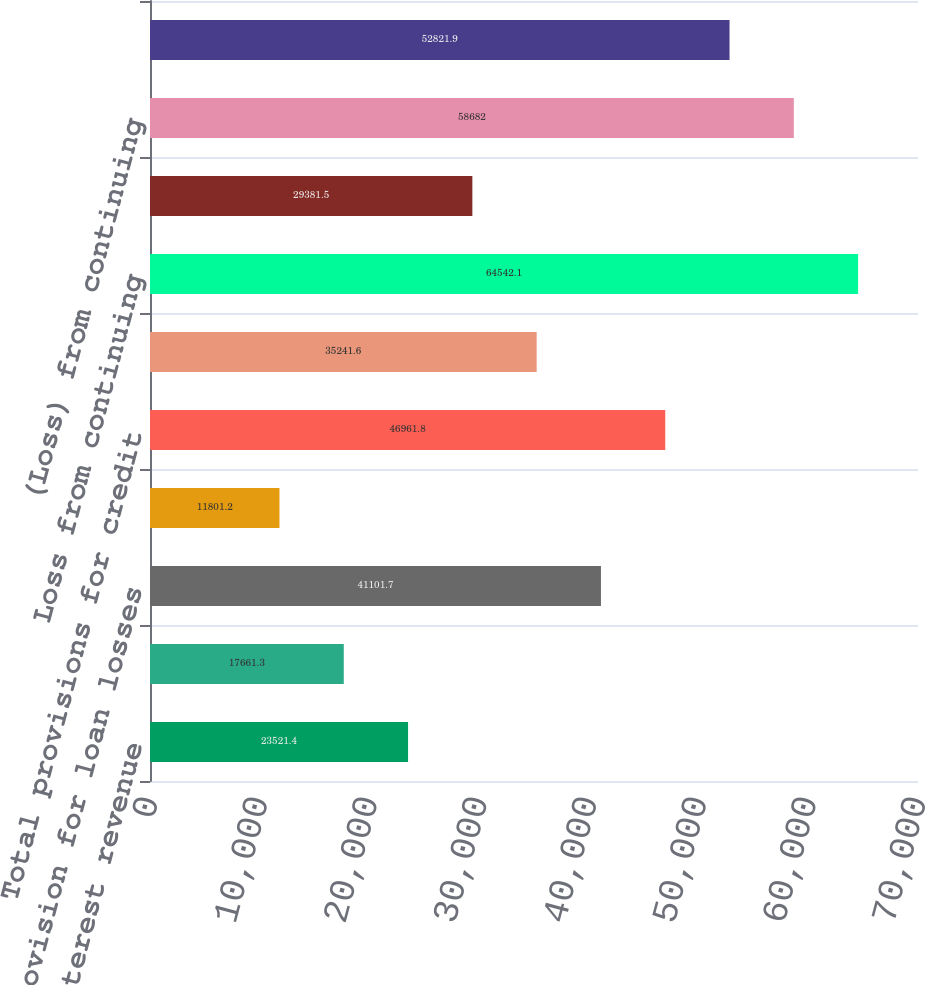<chart> <loc_0><loc_0><loc_500><loc_500><bar_chart><fcel>Net interest revenue<fcel>Net credit losses<fcel>Provision for loan losses<fcel>Provision for benefits and<fcel>Total provisions for credit<fcel>Total operating expenses<fcel>Loss from continuing<fcel>Benefits for income taxes<fcel>(Loss) from continuing<fcel>Citi Holdings net loss<nl><fcel>23521.4<fcel>17661.3<fcel>41101.7<fcel>11801.2<fcel>46961.8<fcel>35241.6<fcel>64542.1<fcel>29381.5<fcel>58682<fcel>52821.9<nl></chart> 